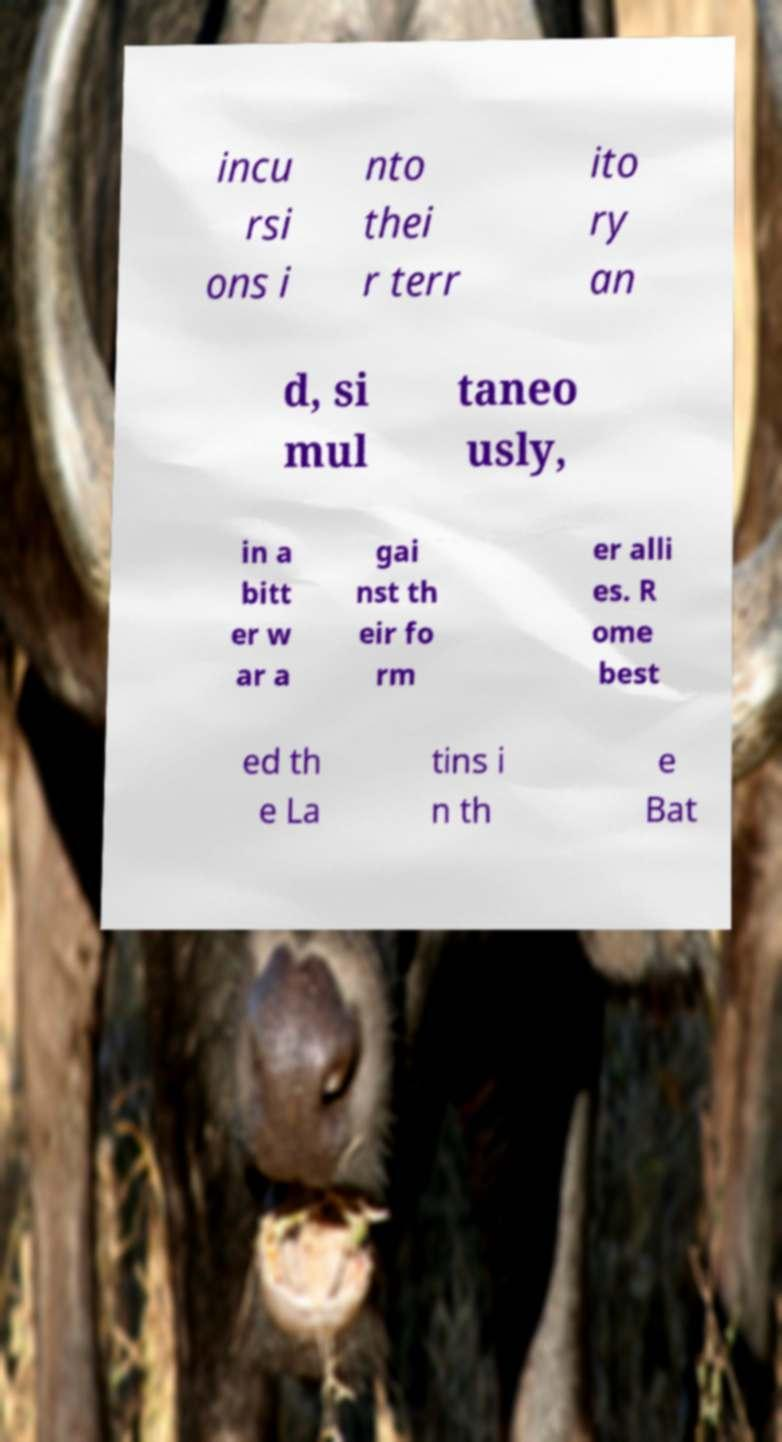Can you accurately transcribe the text from the provided image for me? incu rsi ons i nto thei r terr ito ry an d, si mul taneo usly, in a bitt er w ar a gai nst th eir fo rm er alli es. R ome best ed th e La tins i n th e Bat 